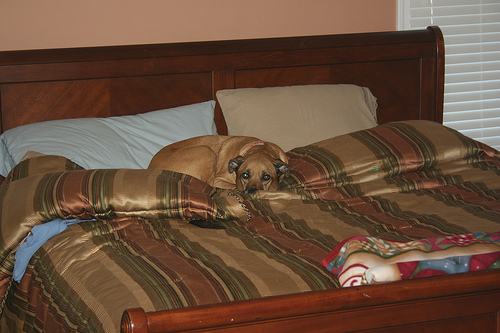<image>
Is the blanket behind the pillow? No. The blanket is not behind the pillow. From this viewpoint, the blanket appears to be positioned elsewhere in the scene. 